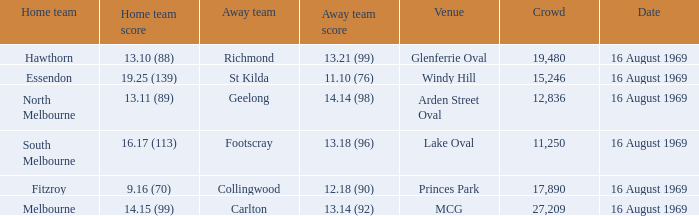When was the game played at Lake Oval? 16 August 1969. 